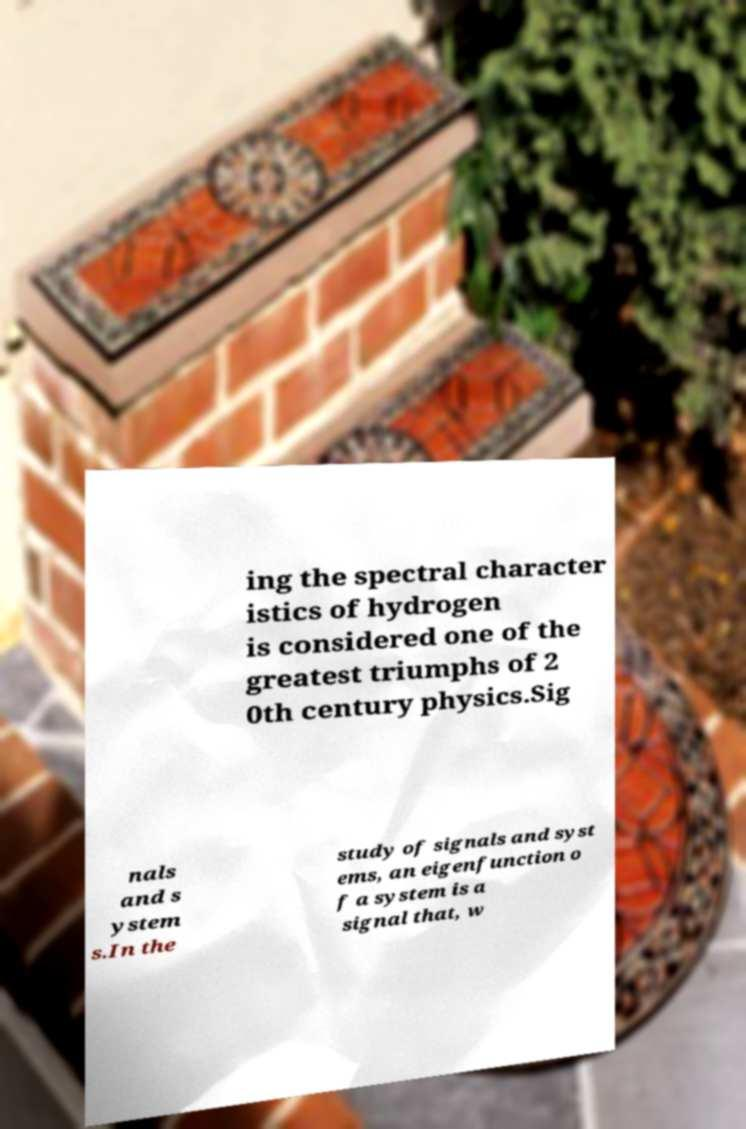Could you extract and type out the text from this image? ing the spectral character istics of hydrogen is considered one of the greatest triumphs of 2 0th century physics.Sig nals and s ystem s.In the study of signals and syst ems, an eigenfunction o f a system is a signal that, w 